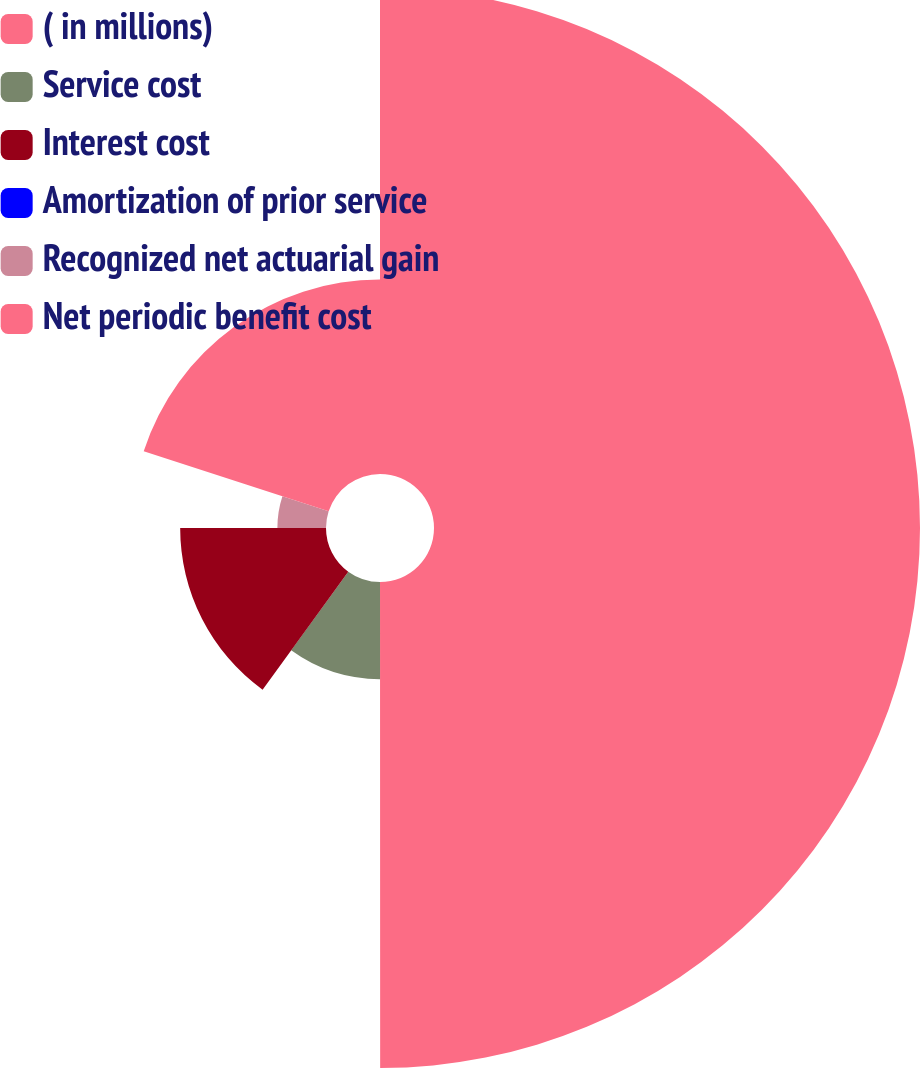Convert chart. <chart><loc_0><loc_0><loc_500><loc_500><pie_chart><fcel>( in millions)<fcel>Service cost<fcel>Interest cost<fcel>Amortization of prior service<fcel>Recognized net actuarial gain<fcel>Net periodic benefit cost<nl><fcel>49.99%<fcel>10.0%<fcel>15.0%<fcel>0.0%<fcel>5.0%<fcel>20.0%<nl></chart> 